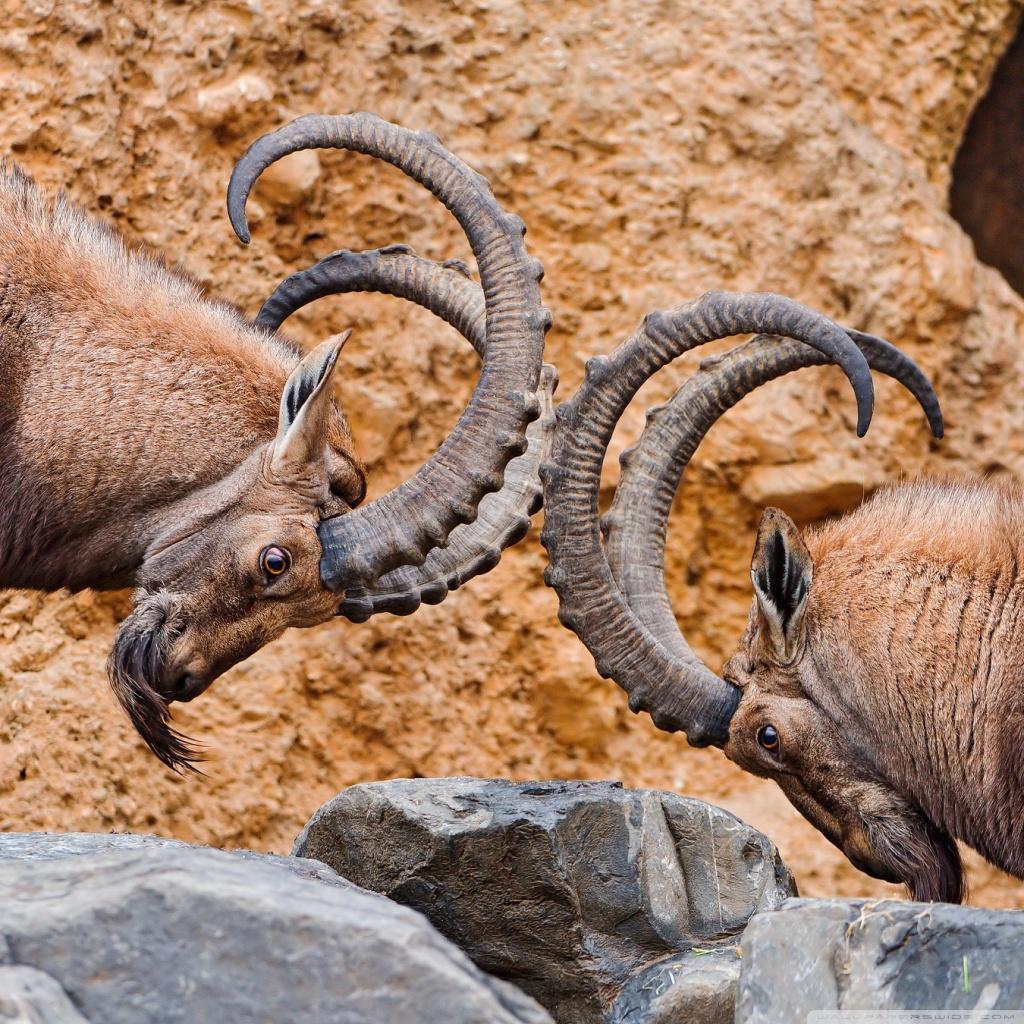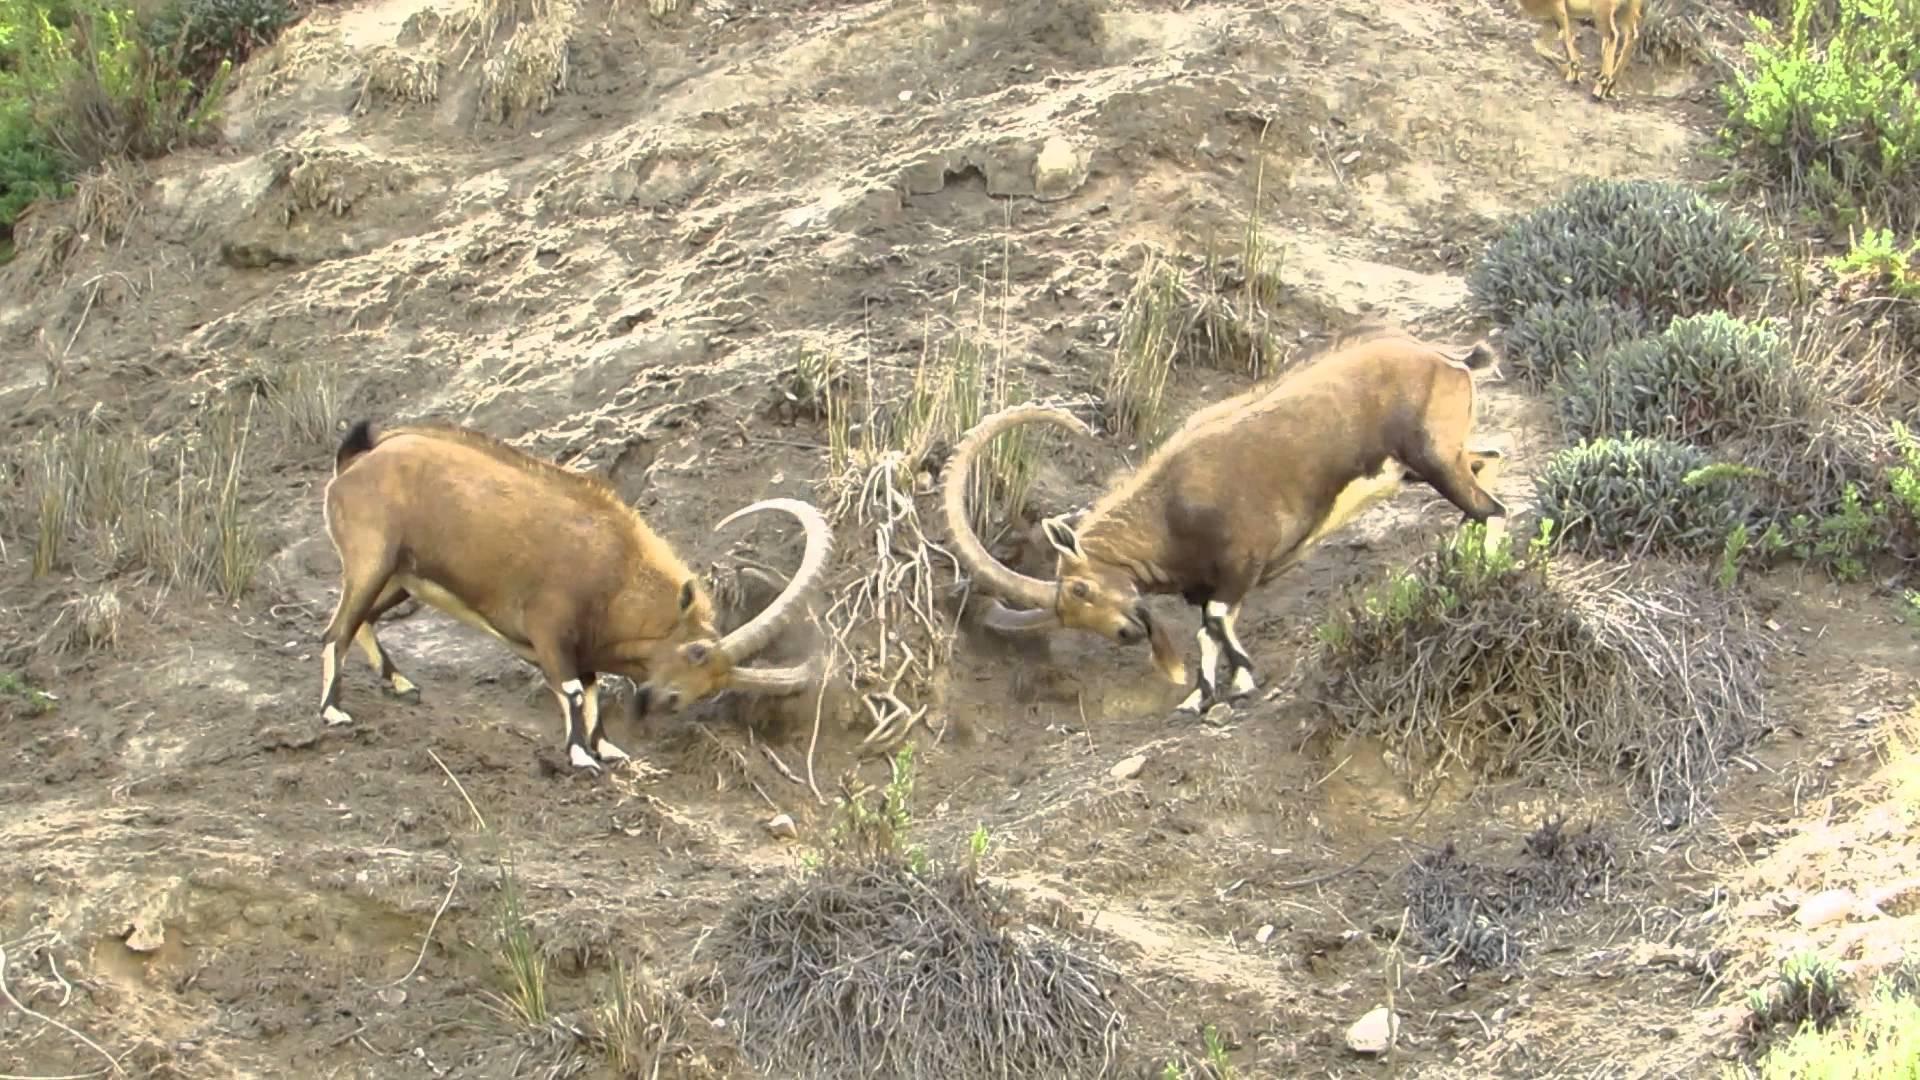The first image is the image on the left, the second image is the image on the right. Assess this claim about the two images: "Two rams are locking horns in each of the images.". Correct or not? Answer yes or no. No. 